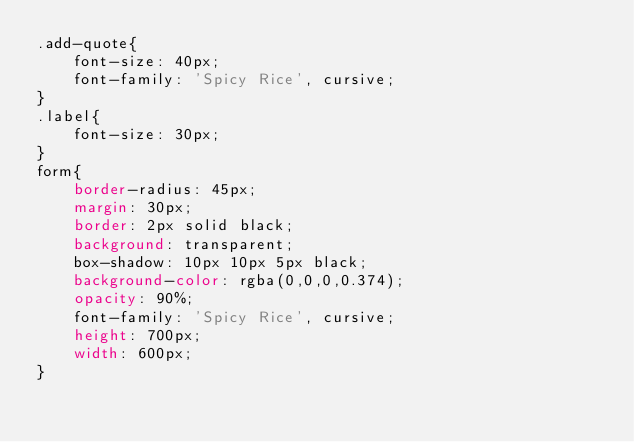<code> <loc_0><loc_0><loc_500><loc_500><_CSS_>.add-quote{
    font-size: 40px;
    font-family: 'Spicy Rice', cursive;
}
.label{
    font-size: 30px;
}
form{
    border-radius: 45px;
    margin: 30px;
    border: 2px solid black;
    background: transparent;
    box-shadow: 10px 10px 5px black;
    background-color: rgba(0,0,0,0.374);
    opacity: 90%;
    font-family: 'Spicy Rice', cursive;
    height: 700px;
    width: 600px;
}</code> 